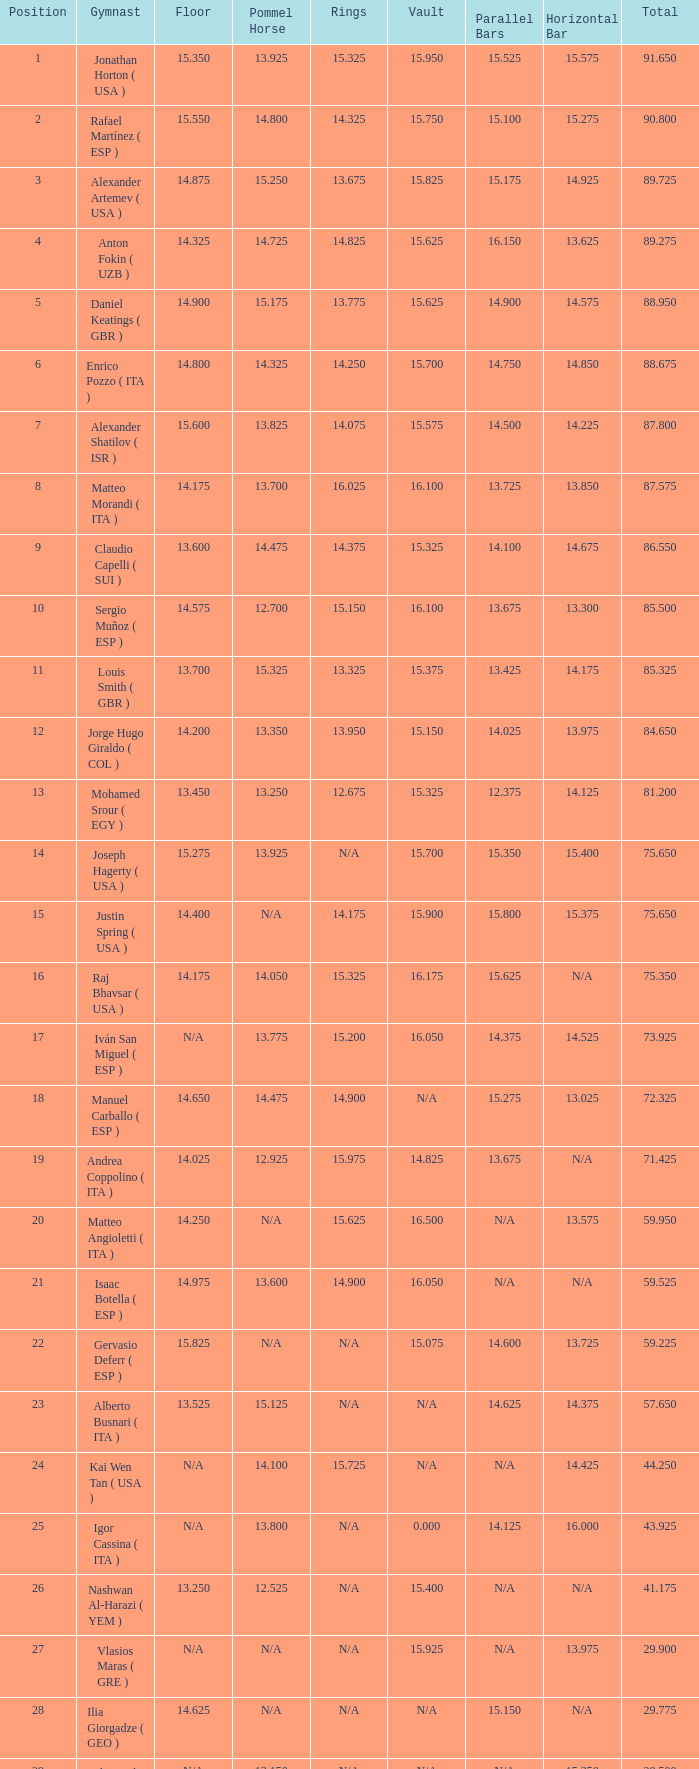When the horizontal bar is not available and the floor's value is 14.175, what is the corresponding number for the parallel bars? 15.625. 